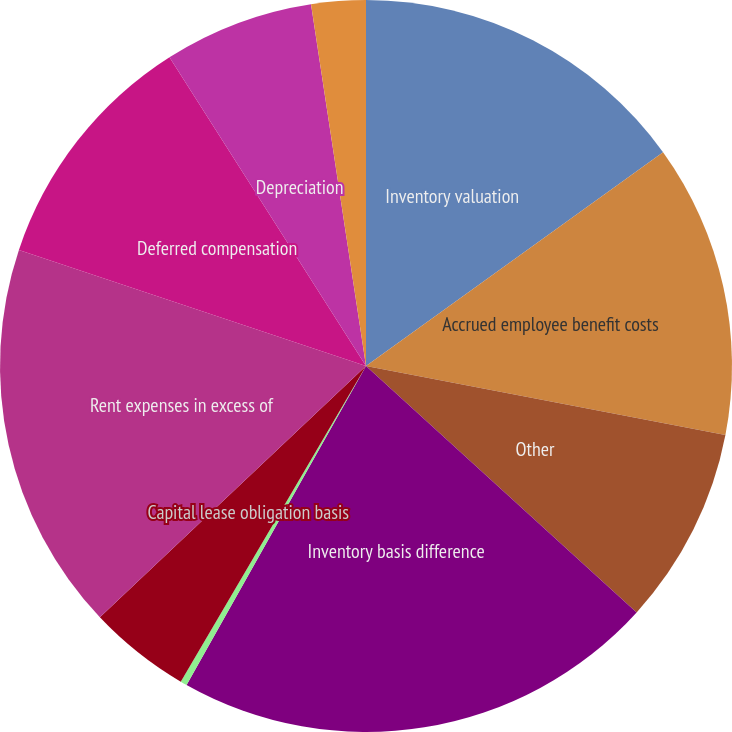Convert chart to OTSL. <chart><loc_0><loc_0><loc_500><loc_500><pie_chart><fcel>Inventory valuation<fcel>Accrued employee benefit costs<fcel>Other<fcel>Inventory basis difference<fcel>Net current tax asset<fcel>Capital lease obligation basis<fcel>Rent expenses in excess of<fcel>Deferred compensation<fcel>Depreciation<fcel>Capital lease assets basis<nl><fcel>15.07%<fcel>12.95%<fcel>8.73%<fcel>21.4%<fcel>0.29%<fcel>4.51%<fcel>17.18%<fcel>10.84%<fcel>6.62%<fcel>2.4%<nl></chart> 